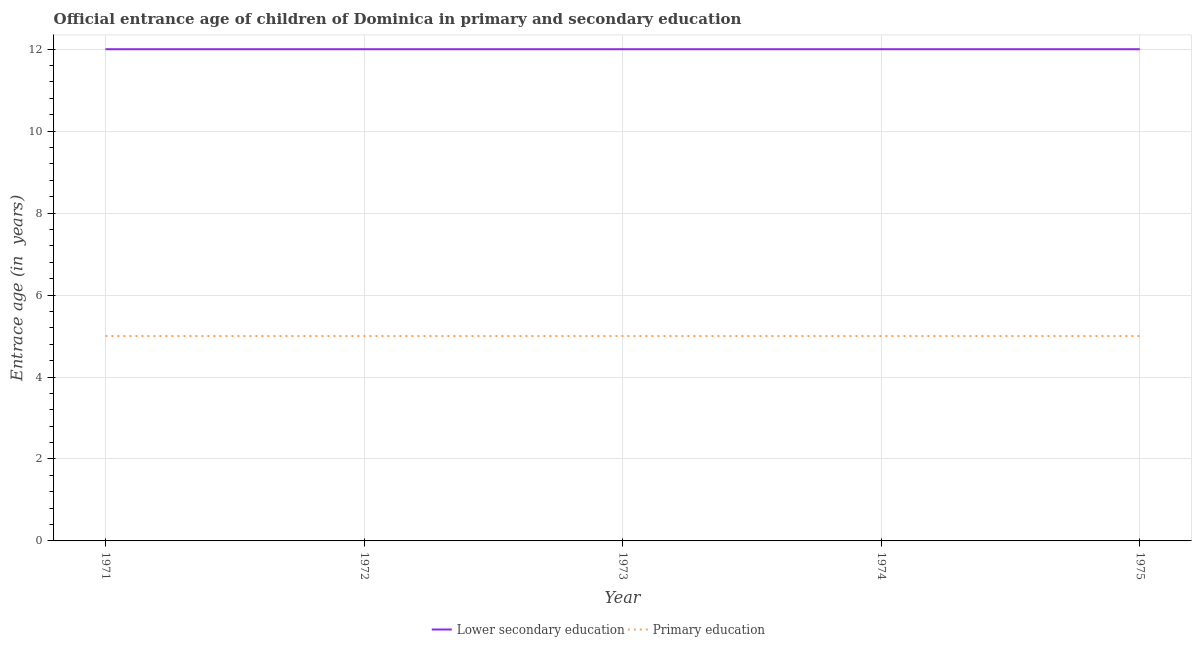How many different coloured lines are there?
Provide a succinct answer. 2. Does the line corresponding to entrance age of chiildren in primary education intersect with the line corresponding to entrance age of children in lower secondary education?
Your response must be concise. No. What is the entrance age of chiildren in primary education in 1973?
Provide a short and direct response. 5. Across all years, what is the maximum entrance age of children in lower secondary education?
Offer a very short reply. 12. Across all years, what is the minimum entrance age of chiildren in primary education?
Give a very brief answer. 5. In which year was the entrance age of children in lower secondary education maximum?
Give a very brief answer. 1971. What is the total entrance age of children in lower secondary education in the graph?
Give a very brief answer. 60. What is the difference between the entrance age of children in lower secondary education in 1971 and that in 1975?
Keep it short and to the point. 0. What is the difference between the entrance age of children in lower secondary education in 1974 and the entrance age of chiildren in primary education in 1973?
Your response must be concise. 7. In the year 1975, what is the difference between the entrance age of children in lower secondary education and entrance age of chiildren in primary education?
Make the answer very short. 7. In how many years, is the entrance age of children in lower secondary education greater than 10.4 years?
Make the answer very short. 5. Is the difference between the entrance age of children in lower secondary education in 1972 and 1974 greater than the difference between the entrance age of chiildren in primary education in 1972 and 1974?
Provide a short and direct response. No. Is the sum of the entrance age of chiildren in primary education in 1972 and 1974 greater than the maximum entrance age of children in lower secondary education across all years?
Make the answer very short. No. Does the entrance age of chiildren in primary education monotonically increase over the years?
Make the answer very short. No. How many lines are there?
Make the answer very short. 2. What is the difference between two consecutive major ticks on the Y-axis?
Offer a very short reply. 2. Where does the legend appear in the graph?
Make the answer very short. Bottom center. What is the title of the graph?
Make the answer very short. Official entrance age of children of Dominica in primary and secondary education. What is the label or title of the Y-axis?
Your response must be concise. Entrace age (in  years). What is the Entrace age (in  years) in Primary education in 1971?
Your answer should be very brief. 5. What is the Entrace age (in  years) of Lower secondary education in 1973?
Your answer should be compact. 12. What is the Entrace age (in  years) in Primary education in 1973?
Your answer should be very brief. 5. What is the Entrace age (in  years) of Lower secondary education in 1974?
Ensure brevity in your answer.  12. What is the Entrace age (in  years) of Primary education in 1974?
Your response must be concise. 5. Across all years, what is the maximum Entrace age (in  years) of Lower secondary education?
Your response must be concise. 12. Across all years, what is the maximum Entrace age (in  years) in Primary education?
Your response must be concise. 5. Across all years, what is the minimum Entrace age (in  years) of Primary education?
Ensure brevity in your answer.  5. What is the difference between the Entrace age (in  years) in Lower secondary education in 1971 and that in 1972?
Provide a succinct answer. 0. What is the difference between the Entrace age (in  years) of Primary education in 1971 and that in 1974?
Give a very brief answer. 0. What is the difference between the Entrace age (in  years) in Lower secondary education in 1971 and that in 1975?
Make the answer very short. 0. What is the difference between the Entrace age (in  years) in Primary education in 1971 and that in 1975?
Make the answer very short. 0. What is the difference between the Entrace age (in  years) in Lower secondary education in 1972 and that in 1973?
Provide a succinct answer. 0. What is the difference between the Entrace age (in  years) of Primary education in 1972 and that in 1974?
Provide a short and direct response. 0. What is the difference between the Entrace age (in  years) in Lower secondary education in 1972 and that in 1975?
Make the answer very short. 0. What is the difference between the Entrace age (in  years) of Lower secondary education in 1973 and that in 1975?
Give a very brief answer. 0. What is the difference between the Entrace age (in  years) of Lower secondary education in 1974 and that in 1975?
Offer a very short reply. 0. What is the difference between the Entrace age (in  years) of Primary education in 1974 and that in 1975?
Provide a succinct answer. 0. What is the difference between the Entrace age (in  years) of Lower secondary education in 1971 and the Entrace age (in  years) of Primary education in 1972?
Keep it short and to the point. 7. What is the difference between the Entrace age (in  years) of Lower secondary education in 1972 and the Entrace age (in  years) of Primary education in 1975?
Provide a succinct answer. 7. What is the difference between the Entrace age (in  years) in Lower secondary education in 1974 and the Entrace age (in  years) in Primary education in 1975?
Give a very brief answer. 7. What is the average Entrace age (in  years) in Primary education per year?
Provide a succinct answer. 5. In the year 1971, what is the difference between the Entrace age (in  years) in Lower secondary education and Entrace age (in  years) in Primary education?
Ensure brevity in your answer.  7. In the year 1972, what is the difference between the Entrace age (in  years) in Lower secondary education and Entrace age (in  years) in Primary education?
Provide a succinct answer. 7. In the year 1973, what is the difference between the Entrace age (in  years) in Lower secondary education and Entrace age (in  years) in Primary education?
Offer a terse response. 7. In the year 1974, what is the difference between the Entrace age (in  years) of Lower secondary education and Entrace age (in  years) of Primary education?
Make the answer very short. 7. What is the ratio of the Entrace age (in  years) of Lower secondary education in 1971 to that in 1973?
Offer a very short reply. 1. What is the ratio of the Entrace age (in  years) in Lower secondary education in 1971 to that in 1975?
Your response must be concise. 1. What is the ratio of the Entrace age (in  years) of Lower secondary education in 1972 to that in 1975?
Make the answer very short. 1. What is the ratio of the Entrace age (in  years) in Primary education in 1973 to that in 1974?
Your answer should be very brief. 1. What is the difference between the highest and the second highest Entrace age (in  years) in Primary education?
Give a very brief answer. 0. What is the difference between the highest and the lowest Entrace age (in  years) in Lower secondary education?
Offer a very short reply. 0. 